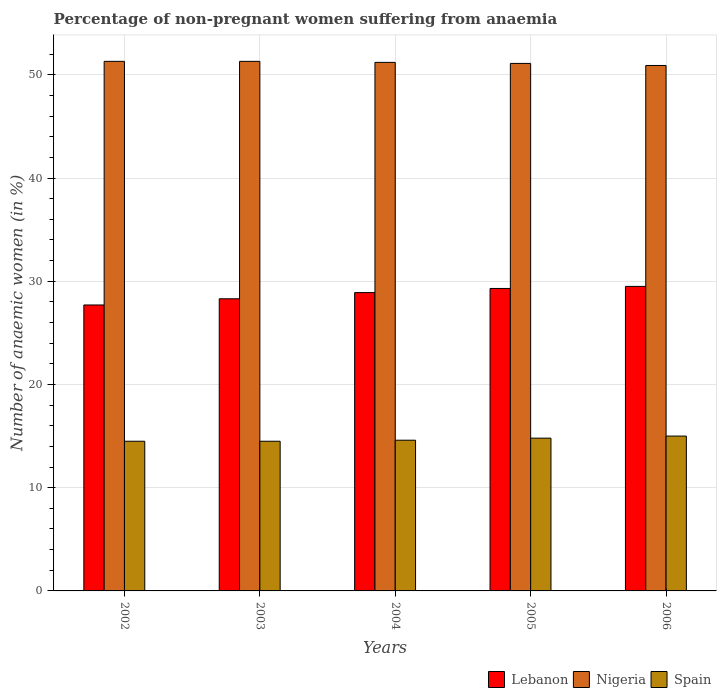How many groups of bars are there?
Give a very brief answer. 5. How many bars are there on the 1st tick from the left?
Offer a very short reply. 3. How many bars are there on the 5th tick from the right?
Your response must be concise. 3. What is the label of the 2nd group of bars from the left?
Offer a terse response. 2003. In how many cases, is the number of bars for a given year not equal to the number of legend labels?
Your response must be concise. 0. What is the percentage of non-pregnant women suffering from anaemia in Lebanon in 2003?
Keep it short and to the point. 28.3. Across all years, what is the maximum percentage of non-pregnant women suffering from anaemia in Nigeria?
Ensure brevity in your answer.  51.3. Across all years, what is the minimum percentage of non-pregnant women suffering from anaemia in Nigeria?
Keep it short and to the point. 50.9. In which year was the percentage of non-pregnant women suffering from anaemia in Spain maximum?
Offer a terse response. 2006. What is the total percentage of non-pregnant women suffering from anaemia in Lebanon in the graph?
Your answer should be very brief. 143.7. What is the difference between the percentage of non-pregnant women suffering from anaemia in Spain in 2002 and that in 2003?
Your answer should be compact. 0. What is the difference between the percentage of non-pregnant women suffering from anaemia in Spain in 2003 and the percentage of non-pregnant women suffering from anaemia in Lebanon in 2002?
Your answer should be compact. -13.2. What is the average percentage of non-pregnant women suffering from anaemia in Spain per year?
Provide a short and direct response. 14.68. What is the ratio of the percentage of non-pregnant women suffering from anaemia in Nigeria in 2002 to that in 2006?
Offer a terse response. 1.01. Is the percentage of non-pregnant women suffering from anaemia in Spain in 2002 less than that in 2005?
Your answer should be compact. Yes. Is the difference between the percentage of non-pregnant women suffering from anaemia in Lebanon in 2002 and 2005 greater than the difference between the percentage of non-pregnant women suffering from anaemia in Spain in 2002 and 2005?
Make the answer very short. No. What is the difference between the highest and the second highest percentage of non-pregnant women suffering from anaemia in Lebanon?
Give a very brief answer. 0.2. What is the difference between the highest and the lowest percentage of non-pregnant women suffering from anaemia in Lebanon?
Your answer should be compact. 1.8. In how many years, is the percentage of non-pregnant women suffering from anaemia in Spain greater than the average percentage of non-pregnant women suffering from anaemia in Spain taken over all years?
Offer a very short reply. 2. What does the 2nd bar from the right in 2003 represents?
Keep it short and to the point. Nigeria. Is it the case that in every year, the sum of the percentage of non-pregnant women suffering from anaemia in Lebanon and percentage of non-pregnant women suffering from anaemia in Spain is greater than the percentage of non-pregnant women suffering from anaemia in Nigeria?
Give a very brief answer. No. How many bars are there?
Provide a succinct answer. 15. Are all the bars in the graph horizontal?
Make the answer very short. No. How many years are there in the graph?
Provide a succinct answer. 5. What is the difference between two consecutive major ticks on the Y-axis?
Provide a succinct answer. 10. Are the values on the major ticks of Y-axis written in scientific E-notation?
Your response must be concise. No. Does the graph contain any zero values?
Offer a very short reply. No. Where does the legend appear in the graph?
Make the answer very short. Bottom right. What is the title of the graph?
Offer a terse response. Percentage of non-pregnant women suffering from anaemia. Does "High income: OECD" appear as one of the legend labels in the graph?
Your response must be concise. No. What is the label or title of the Y-axis?
Make the answer very short. Number of anaemic women (in %). What is the Number of anaemic women (in %) of Lebanon in 2002?
Give a very brief answer. 27.7. What is the Number of anaemic women (in %) of Nigeria in 2002?
Make the answer very short. 51.3. What is the Number of anaemic women (in %) in Lebanon in 2003?
Provide a succinct answer. 28.3. What is the Number of anaemic women (in %) of Nigeria in 2003?
Offer a very short reply. 51.3. What is the Number of anaemic women (in %) of Lebanon in 2004?
Ensure brevity in your answer.  28.9. What is the Number of anaemic women (in %) in Nigeria in 2004?
Your answer should be very brief. 51.2. What is the Number of anaemic women (in %) of Lebanon in 2005?
Your answer should be very brief. 29.3. What is the Number of anaemic women (in %) in Nigeria in 2005?
Offer a terse response. 51.1. What is the Number of anaemic women (in %) in Lebanon in 2006?
Make the answer very short. 29.5. What is the Number of anaemic women (in %) of Nigeria in 2006?
Give a very brief answer. 50.9. Across all years, what is the maximum Number of anaemic women (in %) of Lebanon?
Make the answer very short. 29.5. Across all years, what is the maximum Number of anaemic women (in %) in Nigeria?
Your answer should be compact. 51.3. Across all years, what is the minimum Number of anaemic women (in %) of Lebanon?
Make the answer very short. 27.7. Across all years, what is the minimum Number of anaemic women (in %) of Nigeria?
Your answer should be compact. 50.9. Across all years, what is the minimum Number of anaemic women (in %) in Spain?
Give a very brief answer. 14.5. What is the total Number of anaemic women (in %) of Lebanon in the graph?
Ensure brevity in your answer.  143.7. What is the total Number of anaemic women (in %) in Nigeria in the graph?
Give a very brief answer. 255.8. What is the total Number of anaemic women (in %) of Spain in the graph?
Provide a short and direct response. 73.4. What is the difference between the Number of anaemic women (in %) in Spain in 2002 and that in 2004?
Your answer should be very brief. -0.1. What is the difference between the Number of anaemic women (in %) of Lebanon in 2002 and that in 2005?
Your answer should be very brief. -1.6. What is the difference between the Number of anaemic women (in %) in Lebanon in 2002 and that in 2006?
Keep it short and to the point. -1.8. What is the difference between the Number of anaemic women (in %) of Nigeria in 2002 and that in 2006?
Your answer should be very brief. 0.4. What is the difference between the Number of anaemic women (in %) of Spain in 2002 and that in 2006?
Offer a terse response. -0.5. What is the difference between the Number of anaemic women (in %) in Lebanon in 2003 and that in 2004?
Your answer should be compact. -0.6. What is the difference between the Number of anaemic women (in %) in Lebanon in 2003 and that in 2005?
Your answer should be very brief. -1. What is the difference between the Number of anaemic women (in %) in Nigeria in 2003 and that in 2005?
Keep it short and to the point. 0.2. What is the difference between the Number of anaemic women (in %) in Spain in 2003 and that in 2005?
Your answer should be very brief. -0.3. What is the difference between the Number of anaemic women (in %) in Spain in 2003 and that in 2006?
Ensure brevity in your answer.  -0.5. What is the difference between the Number of anaemic women (in %) in Lebanon in 2004 and that in 2005?
Offer a terse response. -0.4. What is the difference between the Number of anaemic women (in %) of Spain in 2004 and that in 2005?
Keep it short and to the point. -0.2. What is the difference between the Number of anaemic women (in %) of Lebanon in 2004 and that in 2006?
Ensure brevity in your answer.  -0.6. What is the difference between the Number of anaemic women (in %) in Nigeria in 2004 and that in 2006?
Offer a very short reply. 0.3. What is the difference between the Number of anaemic women (in %) of Spain in 2004 and that in 2006?
Offer a terse response. -0.4. What is the difference between the Number of anaemic women (in %) in Lebanon in 2002 and the Number of anaemic women (in %) in Nigeria in 2003?
Ensure brevity in your answer.  -23.6. What is the difference between the Number of anaemic women (in %) of Lebanon in 2002 and the Number of anaemic women (in %) of Spain in 2003?
Make the answer very short. 13.2. What is the difference between the Number of anaemic women (in %) in Nigeria in 2002 and the Number of anaemic women (in %) in Spain in 2003?
Ensure brevity in your answer.  36.8. What is the difference between the Number of anaemic women (in %) in Lebanon in 2002 and the Number of anaemic women (in %) in Nigeria in 2004?
Your answer should be compact. -23.5. What is the difference between the Number of anaemic women (in %) in Lebanon in 2002 and the Number of anaemic women (in %) in Spain in 2004?
Provide a short and direct response. 13.1. What is the difference between the Number of anaemic women (in %) of Nigeria in 2002 and the Number of anaemic women (in %) of Spain in 2004?
Provide a short and direct response. 36.7. What is the difference between the Number of anaemic women (in %) of Lebanon in 2002 and the Number of anaemic women (in %) of Nigeria in 2005?
Offer a very short reply. -23.4. What is the difference between the Number of anaemic women (in %) in Nigeria in 2002 and the Number of anaemic women (in %) in Spain in 2005?
Your response must be concise. 36.5. What is the difference between the Number of anaemic women (in %) of Lebanon in 2002 and the Number of anaemic women (in %) of Nigeria in 2006?
Keep it short and to the point. -23.2. What is the difference between the Number of anaemic women (in %) in Lebanon in 2002 and the Number of anaemic women (in %) in Spain in 2006?
Your response must be concise. 12.7. What is the difference between the Number of anaemic women (in %) of Nigeria in 2002 and the Number of anaemic women (in %) of Spain in 2006?
Ensure brevity in your answer.  36.3. What is the difference between the Number of anaemic women (in %) of Lebanon in 2003 and the Number of anaemic women (in %) of Nigeria in 2004?
Keep it short and to the point. -22.9. What is the difference between the Number of anaemic women (in %) of Lebanon in 2003 and the Number of anaemic women (in %) of Spain in 2004?
Give a very brief answer. 13.7. What is the difference between the Number of anaemic women (in %) of Nigeria in 2003 and the Number of anaemic women (in %) of Spain in 2004?
Offer a terse response. 36.7. What is the difference between the Number of anaemic women (in %) of Lebanon in 2003 and the Number of anaemic women (in %) of Nigeria in 2005?
Provide a short and direct response. -22.8. What is the difference between the Number of anaemic women (in %) of Nigeria in 2003 and the Number of anaemic women (in %) of Spain in 2005?
Provide a succinct answer. 36.5. What is the difference between the Number of anaemic women (in %) of Lebanon in 2003 and the Number of anaemic women (in %) of Nigeria in 2006?
Keep it short and to the point. -22.6. What is the difference between the Number of anaemic women (in %) in Nigeria in 2003 and the Number of anaemic women (in %) in Spain in 2006?
Offer a very short reply. 36.3. What is the difference between the Number of anaemic women (in %) of Lebanon in 2004 and the Number of anaemic women (in %) of Nigeria in 2005?
Offer a terse response. -22.2. What is the difference between the Number of anaemic women (in %) of Lebanon in 2004 and the Number of anaemic women (in %) of Spain in 2005?
Provide a short and direct response. 14.1. What is the difference between the Number of anaemic women (in %) in Nigeria in 2004 and the Number of anaemic women (in %) in Spain in 2005?
Make the answer very short. 36.4. What is the difference between the Number of anaemic women (in %) in Lebanon in 2004 and the Number of anaemic women (in %) in Nigeria in 2006?
Your answer should be compact. -22. What is the difference between the Number of anaemic women (in %) in Nigeria in 2004 and the Number of anaemic women (in %) in Spain in 2006?
Keep it short and to the point. 36.2. What is the difference between the Number of anaemic women (in %) in Lebanon in 2005 and the Number of anaemic women (in %) in Nigeria in 2006?
Your answer should be compact. -21.6. What is the difference between the Number of anaemic women (in %) of Lebanon in 2005 and the Number of anaemic women (in %) of Spain in 2006?
Ensure brevity in your answer.  14.3. What is the difference between the Number of anaemic women (in %) in Nigeria in 2005 and the Number of anaemic women (in %) in Spain in 2006?
Your response must be concise. 36.1. What is the average Number of anaemic women (in %) in Lebanon per year?
Ensure brevity in your answer.  28.74. What is the average Number of anaemic women (in %) of Nigeria per year?
Keep it short and to the point. 51.16. What is the average Number of anaemic women (in %) in Spain per year?
Offer a very short reply. 14.68. In the year 2002, what is the difference between the Number of anaemic women (in %) of Lebanon and Number of anaemic women (in %) of Nigeria?
Your response must be concise. -23.6. In the year 2002, what is the difference between the Number of anaemic women (in %) of Nigeria and Number of anaemic women (in %) of Spain?
Make the answer very short. 36.8. In the year 2003, what is the difference between the Number of anaemic women (in %) of Lebanon and Number of anaemic women (in %) of Nigeria?
Your response must be concise. -23. In the year 2003, what is the difference between the Number of anaemic women (in %) of Lebanon and Number of anaemic women (in %) of Spain?
Make the answer very short. 13.8. In the year 2003, what is the difference between the Number of anaemic women (in %) in Nigeria and Number of anaemic women (in %) in Spain?
Make the answer very short. 36.8. In the year 2004, what is the difference between the Number of anaemic women (in %) of Lebanon and Number of anaemic women (in %) of Nigeria?
Offer a very short reply. -22.3. In the year 2004, what is the difference between the Number of anaemic women (in %) of Lebanon and Number of anaemic women (in %) of Spain?
Your response must be concise. 14.3. In the year 2004, what is the difference between the Number of anaemic women (in %) of Nigeria and Number of anaemic women (in %) of Spain?
Your answer should be compact. 36.6. In the year 2005, what is the difference between the Number of anaemic women (in %) of Lebanon and Number of anaemic women (in %) of Nigeria?
Provide a succinct answer. -21.8. In the year 2005, what is the difference between the Number of anaemic women (in %) of Lebanon and Number of anaemic women (in %) of Spain?
Offer a terse response. 14.5. In the year 2005, what is the difference between the Number of anaemic women (in %) in Nigeria and Number of anaemic women (in %) in Spain?
Offer a terse response. 36.3. In the year 2006, what is the difference between the Number of anaemic women (in %) of Lebanon and Number of anaemic women (in %) of Nigeria?
Ensure brevity in your answer.  -21.4. In the year 2006, what is the difference between the Number of anaemic women (in %) in Lebanon and Number of anaemic women (in %) in Spain?
Your response must be concise. 14.5. In the year 2006, what is the difference between the Number of anaemic women (in %) of Nigeria and Number of anaemic women (in %) of Spain?
Ensure brevity in your answer.  35.9. What is the ratio of the Number of anaemic women (in %) of Lebanon in 2002 to that in 2003?
Offer a terse response. 0.98. What is the ratio of the Number of anaemic women (in %) in Lebanon in 2002 to that in 2004?
Ensure brevity in your answer.  0.96. What is the ratio of the Number of anaemic women (in %) in Spain in 2002 to that in 2004?
Offer a terse response. 0.99. What is the ratio of the Number of anaemic women (in %) in Lebanon in 2002 to that in 2005?
Make the answer very short. 0.95. What is the ratio of the Number of anaemic women (in %) in Nigeria in 2002 to that in 2005?
Give a very brief answer. 1. What is the ratio of the Number of anaemic women (in %) of Spain in 2002 to that in 2005?
Offer a very short reply. 0.98. What is the ratio of the Number of anaemic women (in %) in Lebanon in 2002 to that in 2006?
Offer a very short reply. 0.94. What is the ratio of the Number of anaemic women (in %) of Nigeria in 2002 to that in 2006?
Your answer should be very brief. 1.01. What is the ratio of the Number of anaemic women (in %) in Spain in 2002 to that in 2006?
Your answer should be compact. 0.97. What is the ratio of the Number of anaemic women (in %) in Lebanon in 2003 to that in 2004?
Your answer should be compact. 0.98. What is the ratio of the Number of anaemic women (in %) in Spain in 2003 to that in 2004?
Make the answer very short. 0.99. What is the ratio of the Number of anaemic women (in %) in Lebanon in 2003 to that in 2005?
Your response must be concise. 0.97. What is the ratio of the Number of anaemic women (in %) in Spain in 2003 to that in 2005?
Provide a short and direct response. 0.98. What is the ratio of the Number of anaemic women (in %) of Lebanon in 2003 to that in 2006?
Provide a short and direct response. 0.96. What is the ratio of the Number of anaemic women (in %) of Nigeria in 2003 to that in 2006?
Give a very brief answer. 1.01. What is the ratio of the Number of anaemic women (in %) of Spain in 2003 to that in 2006?
Make the answer very short. 0.97. What is the ratio of the Number of anaemic women (in %) of Lebanon in 2004 to that in 2005?
Your answer should be very brief. 0.99. What is the ratio of the Number of anaemic women (in %) in Nigeria in 2004 to that in 2005?
Your answer should be very brief. 1. What is the ratio of the Number of anaemic women (in %) of Spain in 2004 to that in 2005?
Offer a terse response. 0.99. What is the ratio of the Number of anaemic women (in %) in Lebanon in 2004 to that in 2006?
Ensure brevity in your answer.  0.98. What is the ratio of the Number of anaemic women (in %) of Nigeria in 2004 to that in 2006?
Your answer should be very brief. 1.01. What is the ratio of the Number of anaemic women (in %) in Spain in 2004 to that in 2006?
Ensure brevity in your answer.  0.97. What is the ratio of the Number of anaemic women (in %) in Spain in 2005 to that in 2006?
Your response must be concise. 0.99. What is the difference between the highest and the second highest Number of anaemic women (in %) in Spain?
Offer a terse response. 0.2. What is the difference between the highest and the lowest Number of anaemic women (in %) in Lebanon?
Ensure brevity in your answer.  1.8. 